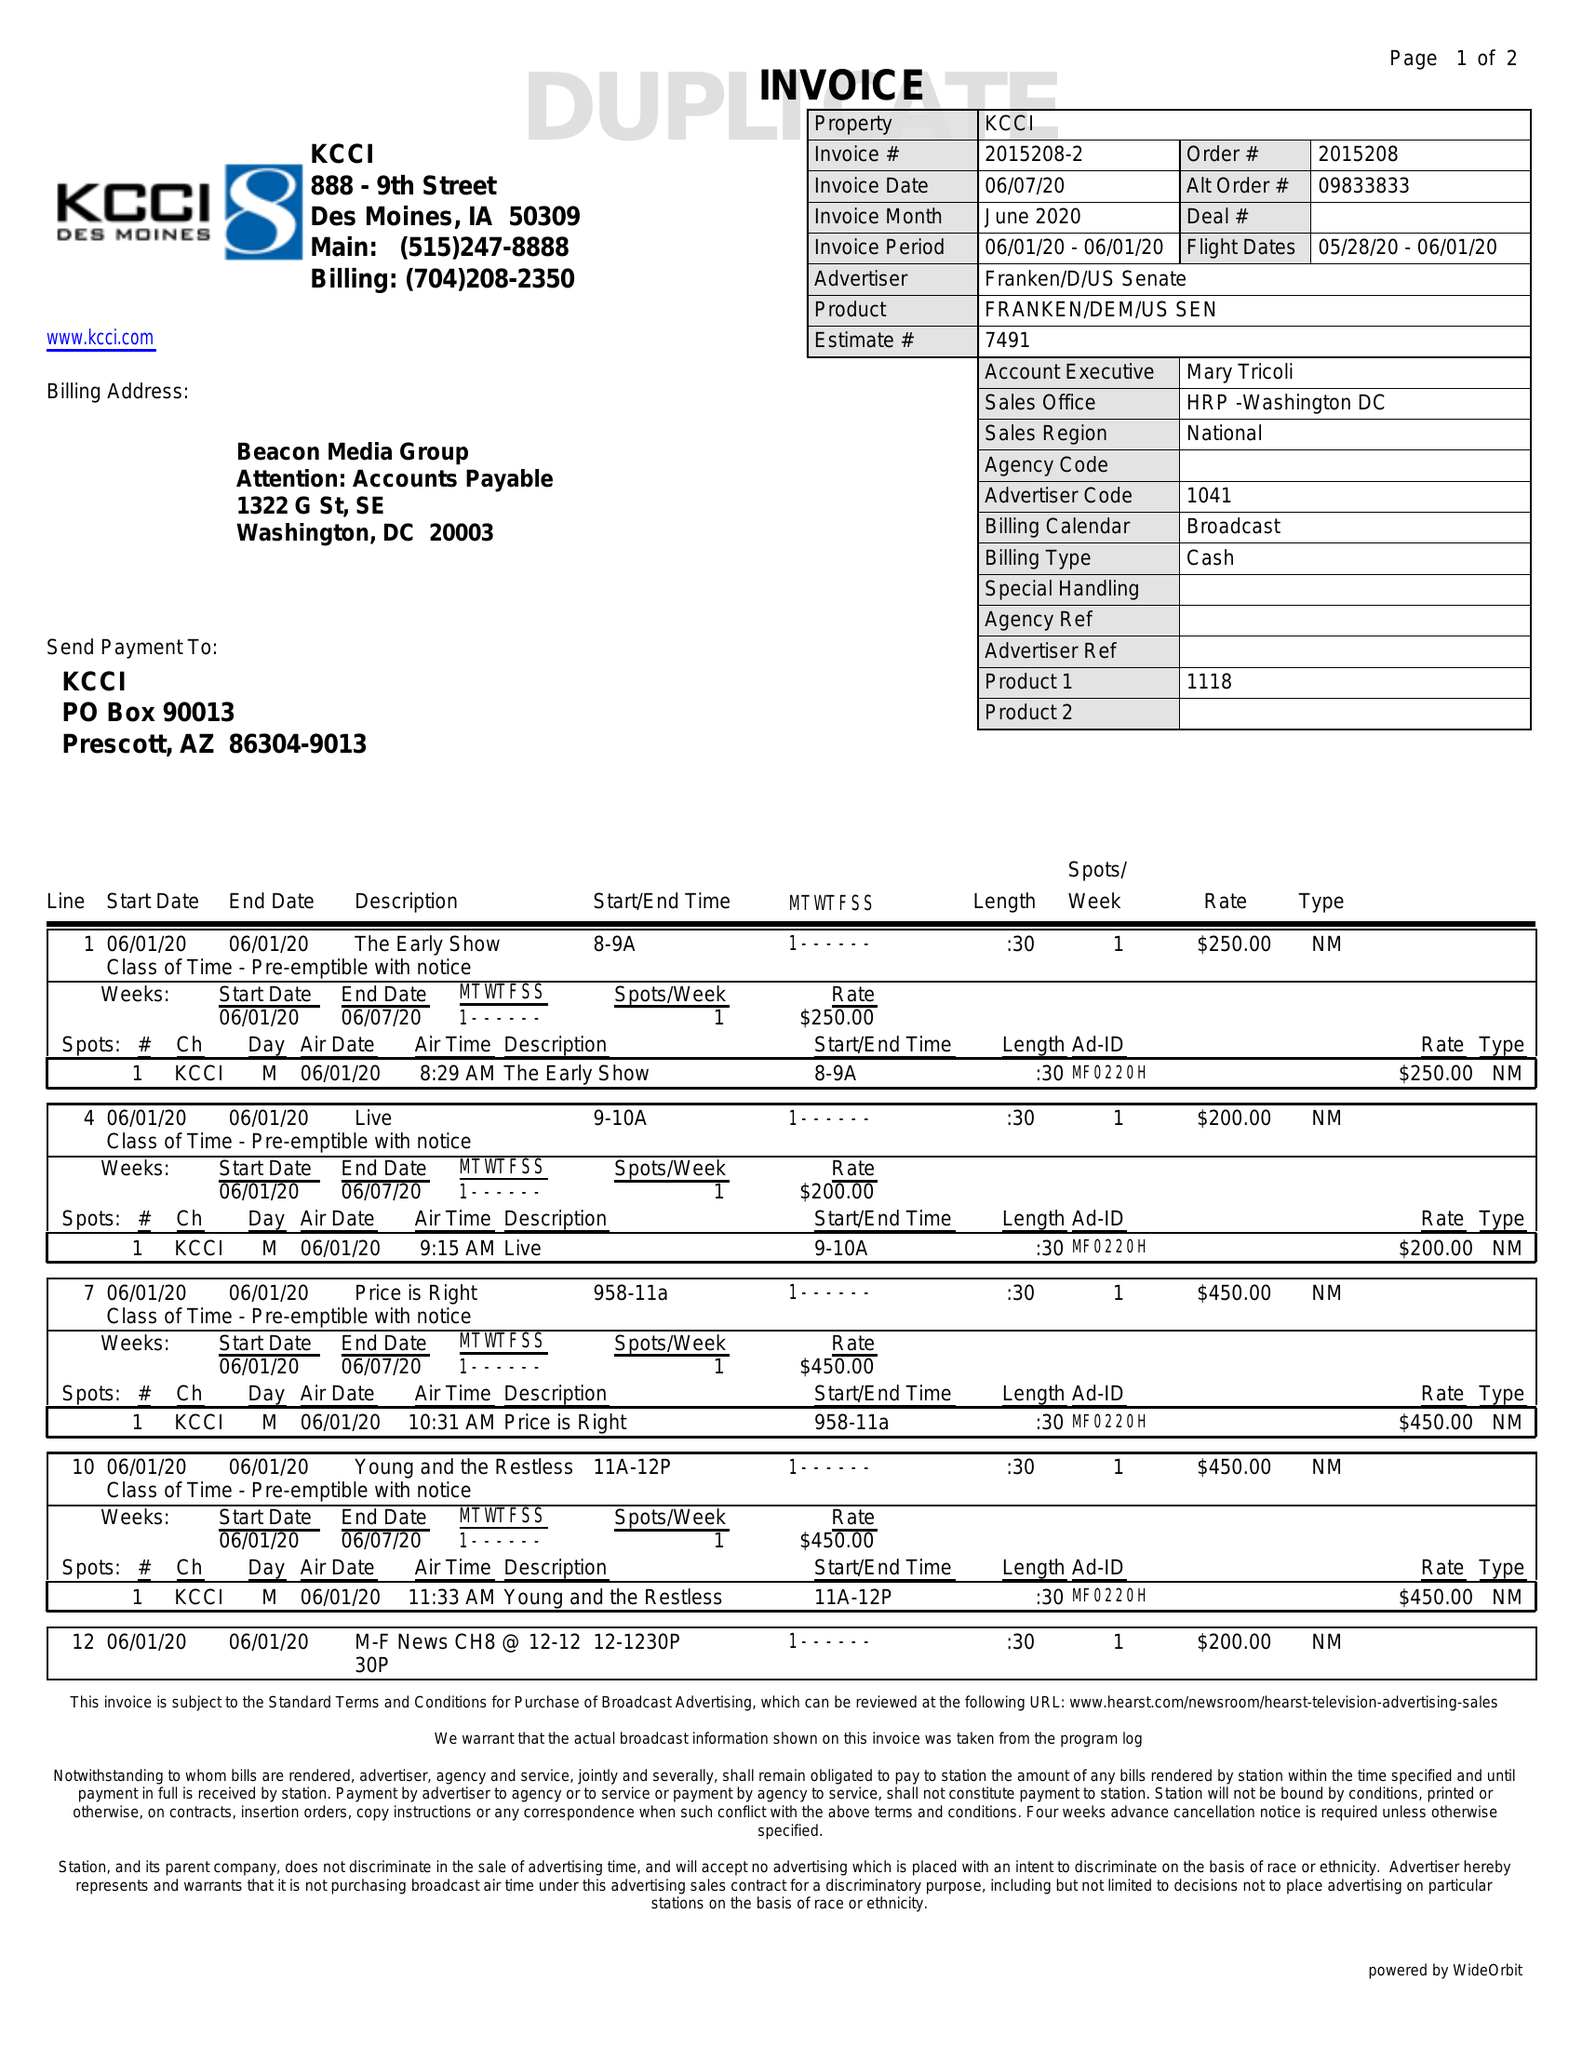What is the value for the flight_from?
Answer the question using a single word or phrase. 05/28/20 